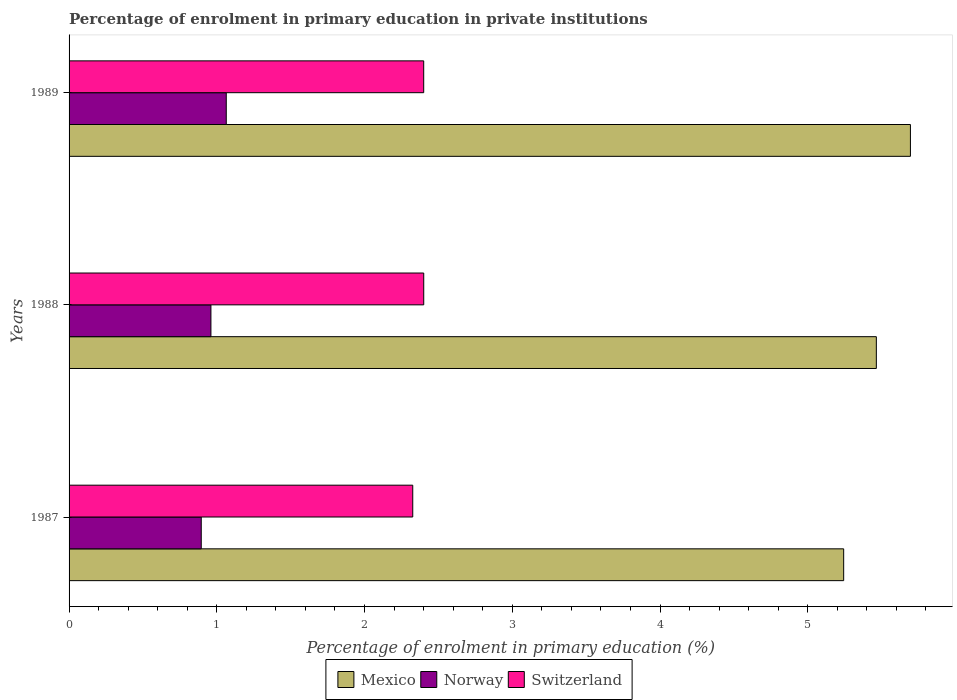Are the number of bars per tick equal to the number of legend labels?
Ensure brevity in your answer.  Yes. How many bars are there on the 2nd tick from the top?
Make the answer very short. 3. How many bars are there on the 2nd tick from the bottom?
Make the answer very short. 3. What is the label of the 1st group of bars from the top?
Offer a very short reply. 1989. In how many cases, is the number of bars for a given year not equal to the number of legend labels?
Give a very brief answer. 0. What is the percentage of enrolment in primary education in Mexico in 1989?
Provide a short and direct response. 5.7. Across all years, what is the maximum percentage of enrolment in primary education in Norway?
Make the answer very short. 1.06. Across all years, what is the minimum percentage of enrolment in primary education in Mexico?
Ensure brevity in your answer.  5.24. What is the total percentage of enrolment in primary education in Norway in the graph?
Keep it short and to the point. 2.92. What is the difference between the percentage of enrolment in primary education in Switzerland in 1988 and that in 1989?
Offer a terse response. 0. What is the difference between the percentage of enrolment in primary education in Norway in 1987 and the percentage of enrolment in primary education in Mexico in 1988?
Give a very brief answer. -4.57. What is the average percentage of enrolment in primary education in Norway per year?
Ensure brevity in your answer.  0.97. In the year 1989, what is the difference between the percentage of enrolment in primary education in Norway and percentage of enrolment in primary education in Mexico?
Ensure brevity in your answer.  -4.63. What is the ratio of the percentage of enrolment in primary education in Norway in 1987 to that in 1989?
Provide a succinct answer. 0.84. Is the percentage of enrolment in primary education in Norway in 1988 less than that in 1989?
Ensure brevity in your answer.  Yes. Is the difference between the percentage of enrolment in primary education in Norway in 1987 and 1988 greater than the difference between the percentage of enrolment in primary education in Mexico in 1987 and 1988?
Keep it short and to the point. Yes. What is the difference between the highest and the second highest percentage of enrolment in primary education in Norway?
Make the answer very short. 0.1. What is the difference between the highest and the lowest percentage of enrolment in primary education in Mexico?
Offer a terse response. 0.45. Is the sum of the percentage of enrolment in primary education in Switzerland in 1988 and 1989 greater than the maximum percentage of enrolment in primary education in Norway across all years?
Your answer should be compact. Yes. What does the 1st bar from the top in 1989 represents?
Your answer should be very brief. Switzerland. Is it the case that in every year, the sum of the percentage of enrolment in primary education in Norway and percentage of enrolment in primary education in Switzerland is greater than the percentage of enrolment in primary education in Mexico?
Provide a short and direct response. No. How many bars are there?
Your answer should be compact. 9. Are all the bars in the graph horizontal?
Provide a succinct answer. Yes. Does the graph contain grids?
Make the answer very short. No. Where does the legend appear in the graph?
Give a very brief answer. Bottom center. How many legend labels are there?
Keep it short and to the point. 3. What is the title of the graph?
Keep it short and to the point. Percentage of enrolment in primary education in private institutions. What is the label or title of the X-axis?
Your answer should be very brief. Percentage of enrolment in primary education (%). What is the Percentage of enrolment in primary education (%) of Mexico in 1987?
Provide a short and direct response. 5.24. What is the Percentage of enrolment in primary education (%) of Norway in 1987?
Provide a short and direct response. 0.89. What is the Percentage of enrolment in primary education (%) of Switzerland in 1987?
Ensure brevity in your answer.  2.33. What is the Percentage of enrolment in primary education (%) of Mexico in 1988?
Make the answer very short. 5.46. What is the Percentage of enrolment in primary education (%) of Norway in 1988?
Provide a succinct answer. 0.96. What is the Percentage of enrolment in primary education (%) in Switzerland in 1988?
Your answer should be very brief. 2.4. What is the Percentage of enrolment in primary education (%) of Mexico in 1989?
Provide a short and direct response. 5.7. What is the Percentage of enrolment in primary education (%) of Norway in 1989?
Your answer should be very brief. 1.06. What is the Percentage of enrolment in primary education (%) of Switzerland in 1989?
Give a very brief answer. 2.4. Across all years, what is the maximum Percentage of enrolment in primary education (%) in Mexico?
Give a very brief answer. 5.7. Across all years, what is the maximum Percentage of enrolment in primary education (%) in Norway?
Ensure brevity in your answer.  1.06. Across all years, what is the maximum Percentage of enrolment in primary education (%) of Switzerland?
Your response must be concise. 2.4. Across all years, what is the minimum Percentage of enrolment in primary education (%) of Mexico?
Keep it short and to the point. 5.24. Across all years, what is the minimum Percentage of enrolment in primary education (%) of Norway?
Ensure brevity in your answer.  0.89. Across all years, what is the minimum Percentage of enrolment in primary education (%) of Switzerland?
Your answer should be very brief. 2.33. What is the total Percentage of enrolment in primary education (%) of Mexico in the graph?
Offer a very short reply. 16.4. What is the total Percentage of enrolment in primary education (%) in Norway in the graph?
Your answer should be very brief. 2.92. What is the total Percentage of enrolment in primary education (%) of Switzerland in the graph?
Offer a very short reply. 7.13. What is the difference between the Percentage of enrolment in primary education (%) of Mexico in 1987 and that in 1988?
Your answer should be compact. -0.22. What is the difference between the Percentage of enrolment in primary education (%) of Norway in 1987 and that in 1988?
Ensure brevity in your answer.  -0.07. What is the difference between the Percentage of enrolment in primary education (%) of Switzerland in 1987 and that in 1988?
Make the answer very short. -0.07. What is the difference between the Percentage of enrolment in primary education (%) in Mexico in 1987 and that in 1989?
Offer a terse response. -0.45. What is the difference between the Percentage of enrolment in primary education (%) of Norway in 1987 and that in 1989?
Provide a short and direct response. -0.17. What is the difference between the Percentage of enrolment in primary education (%) of Switzerland in 1987 and that in 1989?
Offer a very short reply. -0.07. What is the difference between the Percentage of enrolment in primary education (%) of Mexico in 1988 and that in 1989?
Offer a terse response. -0.23. What is the difference between the Percentage of enrolment in primary education (%) in Norway in 1988 and that in 1989?
Offer a terse response. -0.1. What is the difference between the Percentage of enrolment in primary education (%) in Mexico in 1987 and the Percentage of enrolment in primary education (%) in Norway in 1988?
Provide a succinct answer. 4.28. What is the difference between the Percentage of enrolment in primary education (%) of Mexico in 1987 and the Percentage of enrolment in primary education (%) of Switzerland in 1988?
Provide a succinct answer. 2.84. What is the difference between the Percentage of enrolment in primary education (%) in Norway in 1987 and the Percentage of enrolment in primary education (%) in Switzerland in 1988?
Your response must be concise. -1.51. What is the difference between the Percentage of enrolment in primary education (%) in Mexico in 1987 and the Percentage of enrolment in primary education (%) in Norway in 1989?
Ensure brevity in your answer.  4.18. What is the difference between the Percentage of enrolment in primary education (%) in Mexico in 1987 and the Percentage of enrolment in primary education (%) in Switzerland in 1989?
Your response must be concise. 2.84. What is the difference between the Percentage of enrolment in primary education (%) of Norway in 1987 and the Percentage of enrolment in primary education (%) of Switzerland in 1989?
Your answer should be compact. -1.51. What is the difference between the Percentage of enrolment in primary education (%) of Mexico in 1988 and the Percentage of enrolment in primary education (%) of Norway in 1989?
Offer a very short reply. 4.4. What is the difference between the Percentage of enrolment in primary education (%) in Mexico in 1988 and the Percentage of enrolment in primary education (%) in Switzerland in 1989?
Ensure brevity in your answer.  3.06. What is the difference between the Percentage of enrolment in primary education (%) in Norway in 1988 and the Percentage of enrolment in primary education (%) in Switzerland in 1989?
Ensure brevity in your answer.  -1.44. What is the average Percentage of enrolment in primary education (%) in Mexico per year?
Give a very brief answer. 5.47. What is the average Percentage of enrolment in primary education (%) of Switzerland per year?
Your response must be concise. 2.38. In the year 1987, what is the difference between the Percentage of enrolment in primary education (%) in Mexico and Percentage of enrolment in primary education (%) in Norway?
Provide a succinct answer. 4.35. In the year 1987, what is the difference between the Percentage of enrolment in primary education (%) of Mexico and Percentage of enrolment in primary education (%) of Switzerland?
Provide a short and direct response. 2.92. In the year 1987, what is the difference between the Percentage of enrolment in primary education (%) of Norway and Percentage of enrolment in primary education (%) of Switzerland?
Offer a terse response. -1.43. In the year 1988, what is the difference between the Percentage of enrolment in primary education (%) in Mexico and Percentage of enrolment in primary education (%) in Norway?
Ensure brevity in your answer.  4.5. In the year 1988, what is the difference between the Percentage of enrolment in primary education (%) in Mexico and Percentage of enrolment in primary education (%) in Switzerland?
Make the answer very short. 3.06. In the year 1988, what is the difference between the Percentage of enrolment in primary education (%) of Norway and Percentage of enrolment in primary education (%) of Switzerland?
Provide a succinct answer. -1.44. In the year 1989, what is the difference between the Percentage of enrolment in primary education (%) in Mexico and Percentage of enrolment in primary education (%) in Norway?
Provide a short and direct response. 4.63. In the year 1989, what is the difference between the Percentage of enrolment in primary education (%) in Mexico and Percentage of enrolment in primary education (%) in Switzerland?
Your answer should be compact. 3.29. In the year 1989, what is the difference between the Percentage of enrolment in primary education (%) of Norway and Percentage of enrolment in primary education (%) of Switzerland?
Make the answer very short. -1.34. What is the ratio of the Percentage of enrolment in primary education (%) in Mexico in 1987 to that in 1988?
Offer a very short reply. 0.96. What is the ratio of the Percentage of enrolment in primary education (%) in Norway in 1987 to that in 1988?
Your answer should be compact. 0.93. What is the ratio of the Percentage of enrolment in primary education (%) in Switzerland in 1987 to that in 1988?
Your answer should be very brief. 0.97. What is the ratio of the Percentage of enrolment in primary education (%) in Mexico in 1987 to that in 1989?
Offer a very short reply. 0.92. What is the ratio of the Percentage of enrolment in primary education (%) of Norway in 1987 to that in 1989?
Your response must be concise. 0.84. What is the ratio of the Percentage of enrolment in primary education (%) of Switzerland in 1987 to that in 1989?
Your answer should be very brief. 0.97. What is the ratio of the Percentage of enrolment in primary education (%) of Mexico in 1988 to that in 1989?
Keep it short and to the point. 0.96. What is the ratio of the Percentage of enrolment in primary education (%) in Norway in 1988 to that in 1989?
Provide a short and direct response. 0.9. What is the difference between the highest and the second highest Percentage of enrolment in primary education (%) of Mexico?
Your response must be concise. 0.23. What is the difference between the highest and the second highest Percentage of enrolment in primary education (%) of Norway?
Keep it short and to the point. 0.1. What is the difference between the highest and the second highest Percentage of enrolment in primary education (%) in Switzerland?
Your answer should be very brief. 0. What is the difference between the highest and the lowest Percentage of enrolment in primary education (%) of Mexico?
Your response must be concise. 0.45. What is the difference between the highest and the lowest Percentage of enrolment in primary education (%) in Norway?
Your answer should be very brief. 0.17. What is the difference between the highest and the lowest Percentage of enrolment in primary education (%) of Switzerland?
Ensure brevity in your answer.  0.07. 